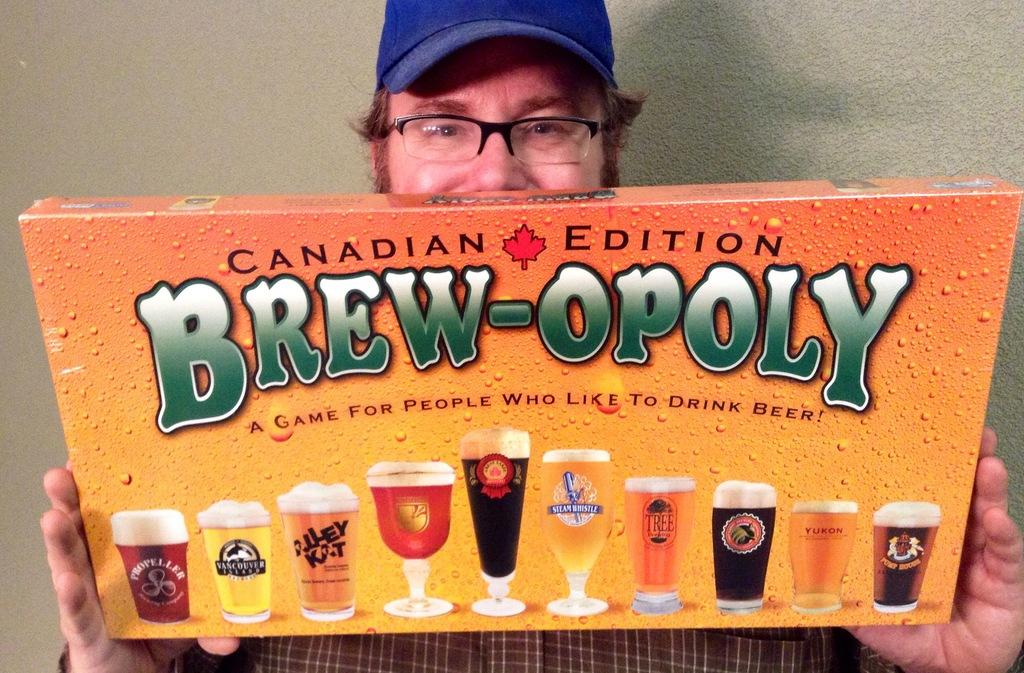Provide a one-sentence caption for the provided image. A man holds and shows off a board game called Canadian Edition Brew-opoly. 